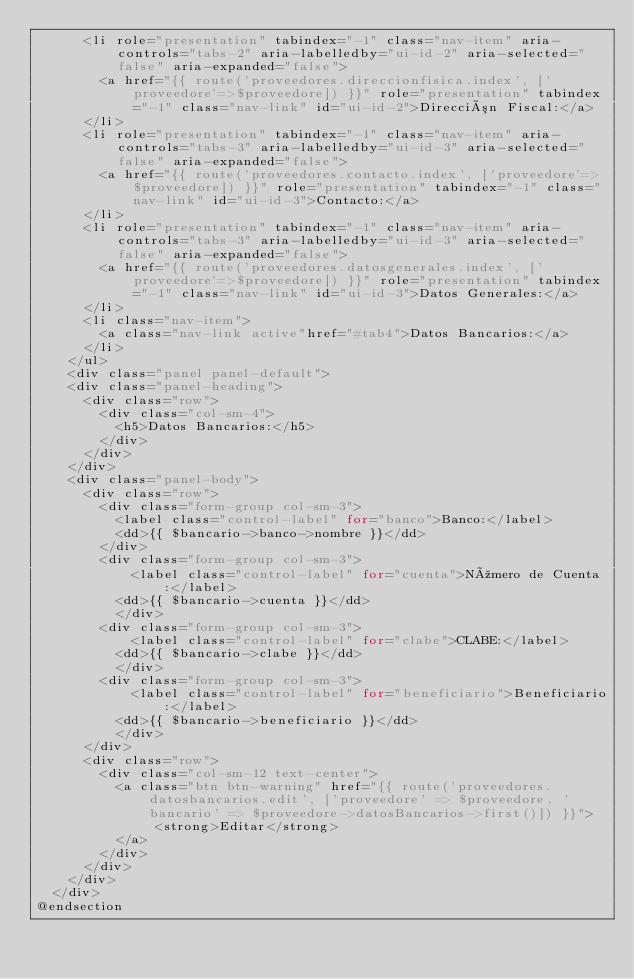<code> <loc_0><loc_0><loc_500><loc_500><_PHP_>			<li role="presentation" tabindex="-1" class="nav-item" aria-controls="tabs-2" aria-labelledby="ui-id-2" aria-selected="false" aria-expanded="false">
				<a href="{{ route('proveedores.direccionfisica.index', ['proveedore'=>$proveedore]) }}" role="presentation" tabindex="-1" class="nav-link" id="ui-id-2">Dirección Fiscal:</a>
			</li>
			<li role="presentation" tabindex="-1" class="nav-item" aria-controls="tabs-3" aria-labelledby="ui-id-3" aria-selected="false" aria-expanded="false">
				<a href="{{ route('proveedores.contacto.index', ['proveedore'=>$proveedore]) }}" role="presentation" tabindex="-1" class="nav-link" id="ui-id-3">Contacto:</a>
			</li>
			<li role="presentation" tabindex="-1" class="nav-item" aria-controls="tabs-3" aria-labelledby="ui-id-3" aria-selected="false" aria-expanded="false">
				<a href="{{ route('proveedores.datosgenerales.index', ['proveedore'=>$proveedore]) }}" role="presentation" tabindex="-1" class="nav-link" id="ui-id-3">Datos Generales:</a>
			</li>
			<li class="nav-item">
				<a class="nav-link active"href="#tab4">Datos Bancarios:</a>
			</li>
		</ul>
		<div class="panel panel-default">
		<div class="panel-heading">
			<div class="row">
				<div class="col-sm-4">
					<h5>Datos Bancarios:</h5>
				</div>
			</div>
		</div>
		<div class="panel-body">
			<div class="row">
				<div class="form-group col-sm-3">
					<label class="control-label" for="banco">Banco:</label>
					<dd>{{ $bancario->banco->nombre }}</dd>
				</div>
				<div class="form-group col-sm-3">
						<label class="control-label" for="cuenta">Número de Cuenta:</label>
					<dd>{{ $bancario->cuenta }}</dd>
					</div>
				<div class="form-group col-sm-3">
						<label class="control-label" for="clabe">CLABE:</label>
					<dd>{{ $bancario->clabe }}</dd>
					</div>
				<div class="form-group col-sm-3">
						<label class="control-label" for="beneficiario">Beneficiario:</label>
					<dd>{{ $bancario->beneficiario }}</dd>
					</div>
			</div>
			<div class="row">
				<div class="col-sm-12 text-center">
					<a class="btn btn-warning" href="{{ route('proveedores.datosbancarios.edit', ['proveedore' => $proveedore, 'bancario' => $proveedore->datosBancarios->first()]) }}">
				       <strong>Editar</strong>
					</a>
				</div>
			</div>
		</div>
	</div>
@endsection</code> 